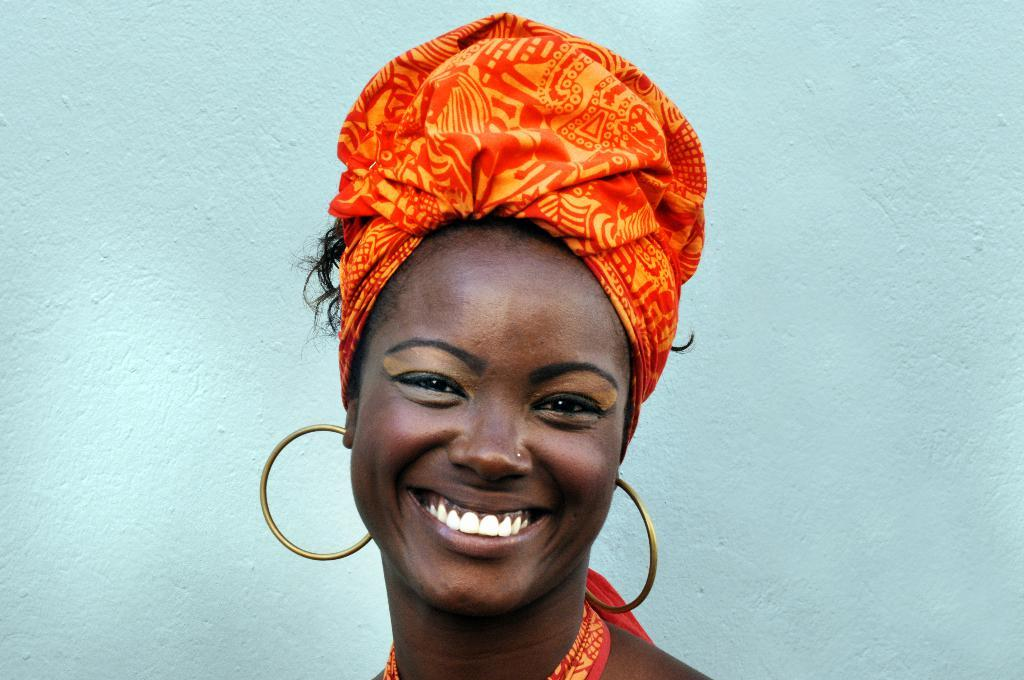Who is present in the image? There is a woman in the image. What is the woman's facial expression? The woman is smiling. What can be seen in the background of the image? There is a wall in the background of the image. How many pets can be seen in the image? There are no pets visible in the image. What type of stone is the woman standing on in the image? There is no stone present in the image; the woman is standing on a floor or ground surface. 